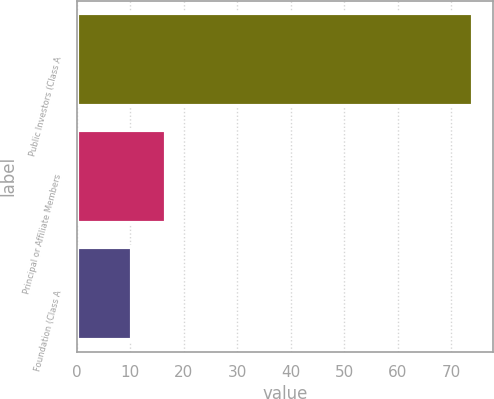<chart> <loc_0><loc_0><loc_500><loc_500><bar_chart><fcel>Public Investors (Class A<fcel>Principal or Affiliate Members<fcel>Foundation (Class A<nl><fcel>74.2<fcel>16.78<fcel>10.4<nl></chart> 